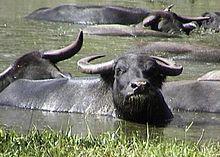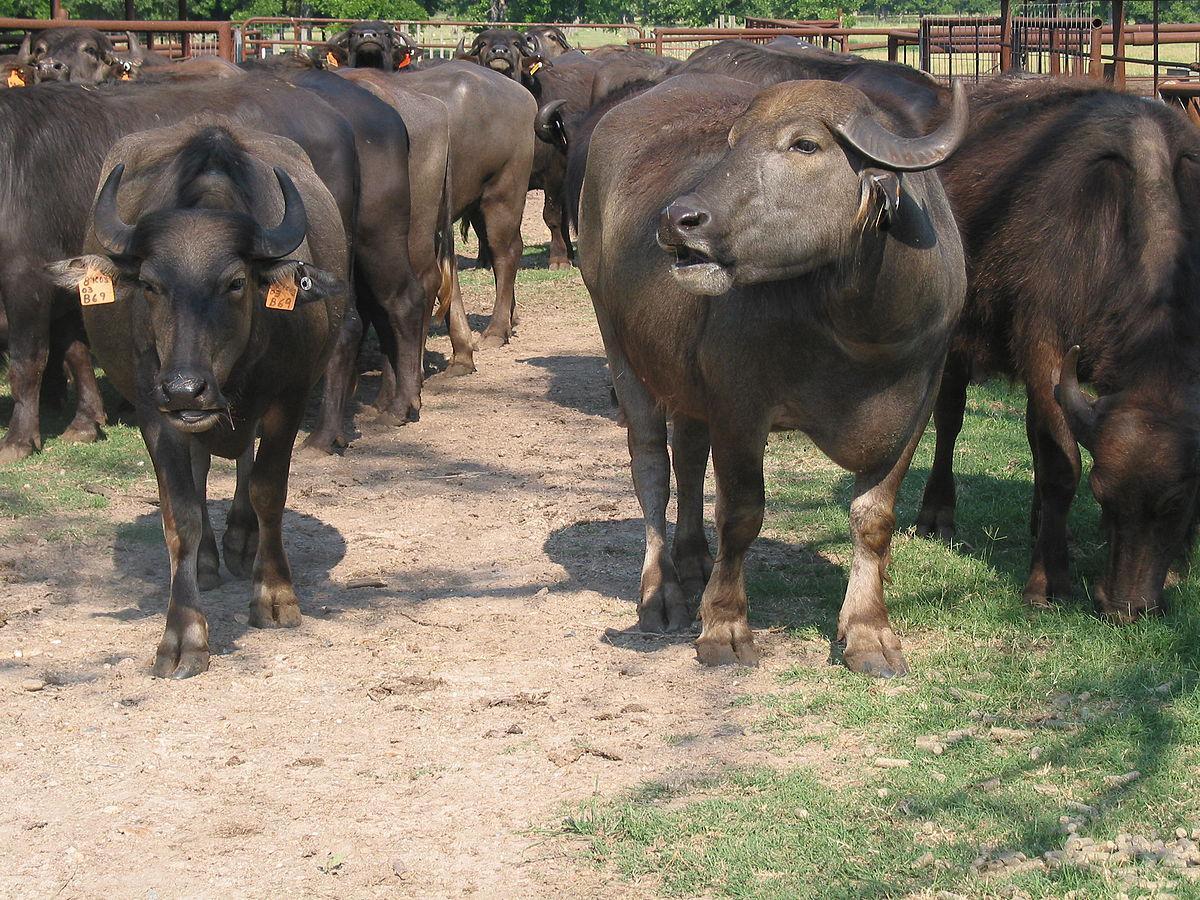The first image is the image on the left, the second image is the image on the right. For the images displayed, is the sentence "There are two bison-like creatures only." factually correct? Answer yes or no. No. 